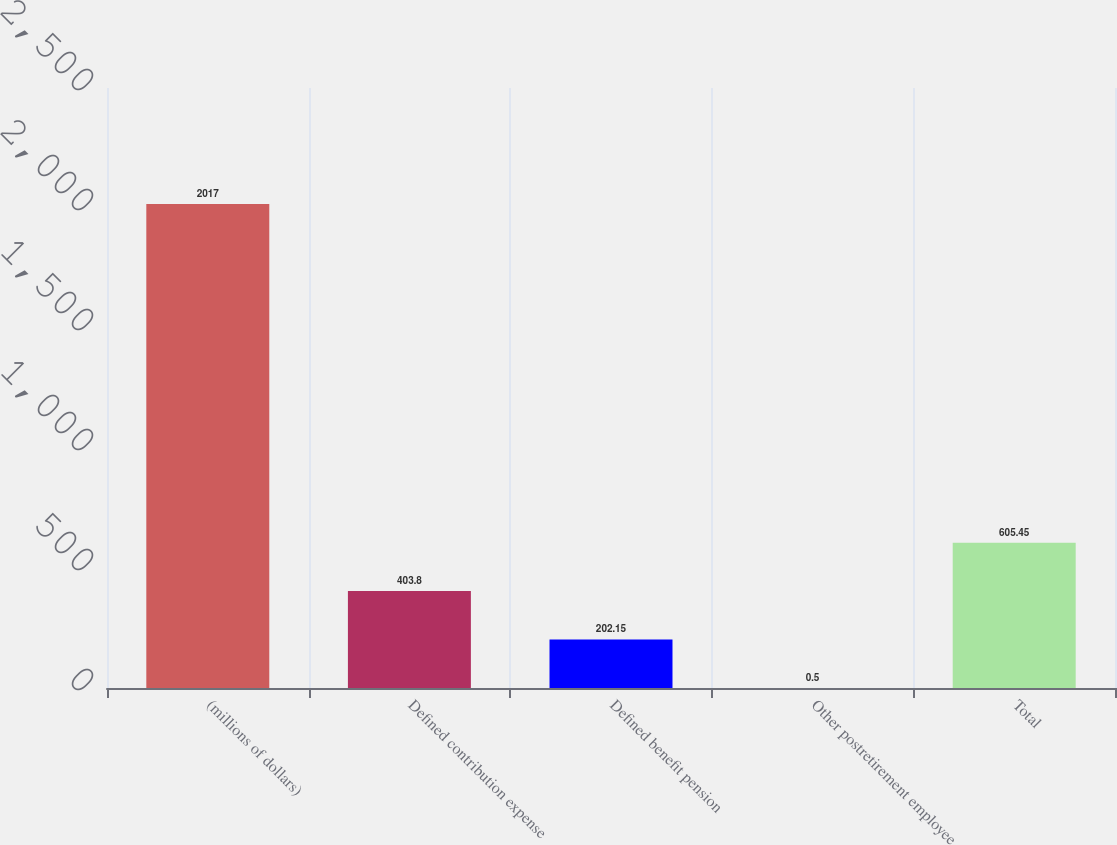Convert chart. <chart><loc_0><loc_0><loc_500><loc_500><bar_chart><fcel>(millions of dollars)<fcel>Defined contribution expense<fcel>Defined benefit pension<fcel>Other postretirement employee<fcel>Total<nl><fcel>2017<fcel>403.8<fcel>202.15<fcel>0.5<fcel>605.45<nl></chart> 